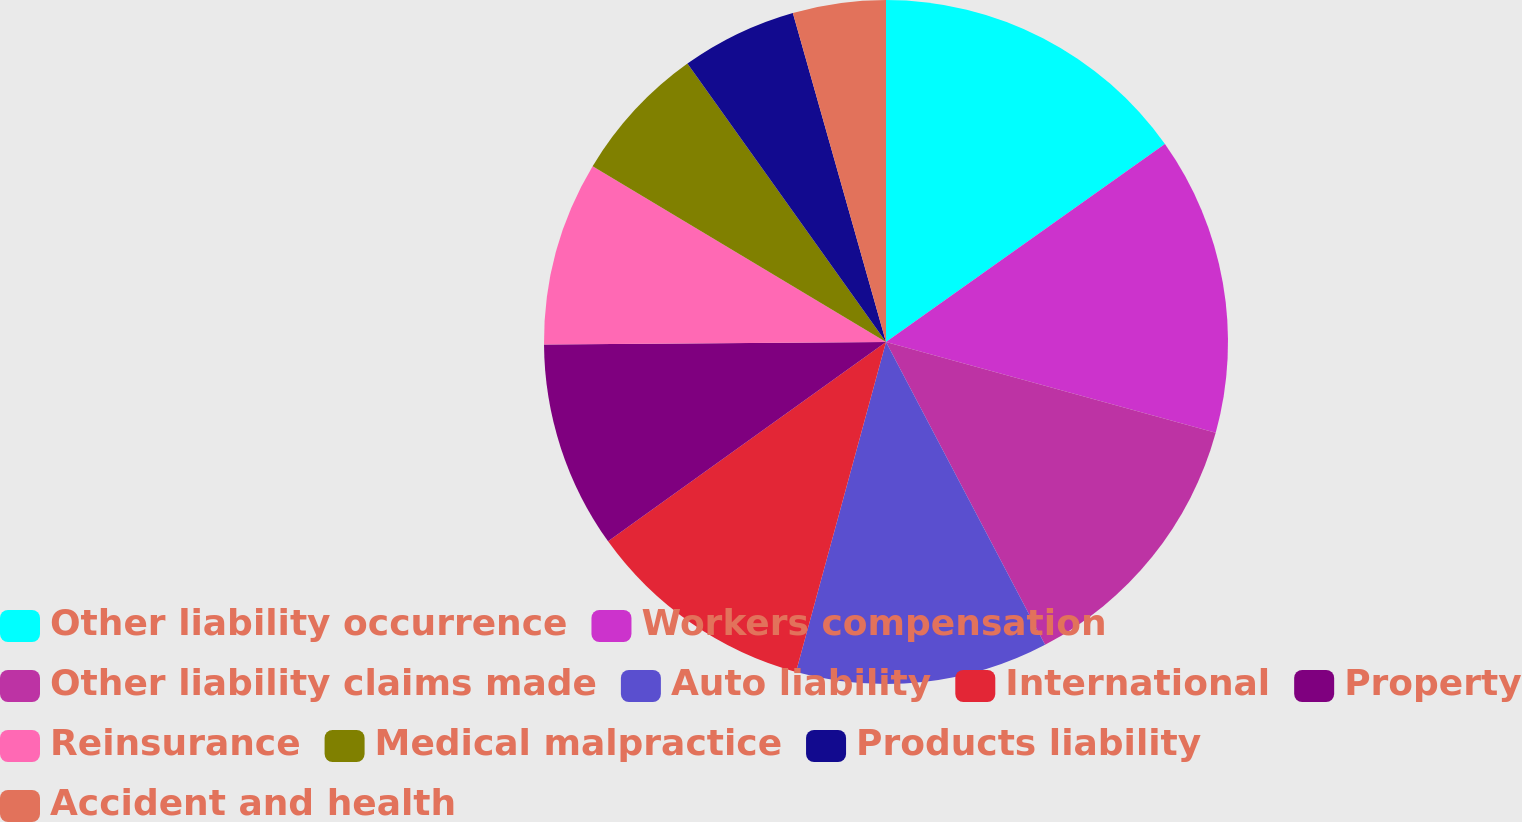<chart> <loc_0><loc_0><loc_500><loc_500><pie_chart><fcel>Other liability occurrence<fcel>Workers compensation<fcel>Other liability claims made<fcel>Auto liability<fcel>International<fcel>Property<fcel>Reinsurance<fcel>Medical malpractice<fcel>Products liability<fcel>Accident and health<nl><fcel>15.18%<fcel>14.1%<fcel>13.02%<fcel>11.94%<fcel>10.86%<fcel>9.78%<fcel>8.71%<fcel>6.55%<fcel>5.47%<fcel>4.39%<nl></chart> 